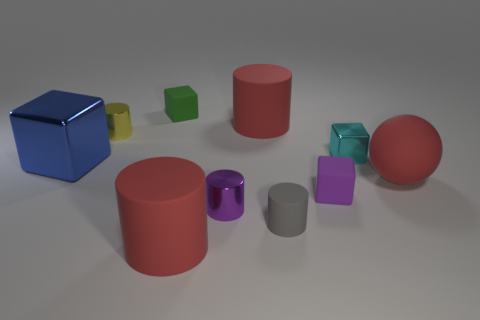Are there any other things that are the same shape as the tiny purple shiny thing?
Offer a very short reply. Yes. The big thing that is on the left side of the matte block behind the blue metal thing is made of what material?
Offer a terse response. Metal. How big is the red matte ball that is to the right of the small purple shiny object?
Your response must be concise. Large. There is a large matte object that is left of the cyan object and behind the tiny gray rubber object; what color is it?
Ensure brevity in your answer.  Red. There is a red matte cylinder behind the red rubber ball; is it the same size as the green rubber object?
Offer a very short reply. No. Is there a tiny gray matte cylinder to the left of the metal cylinder that is behind the tiny cyan shiny object?
Offer a very short reply. No. What is the material of the red ball?
Your answer should be compact. Rubber. Are there any gray objects to the left of the purple shiny thing?
Offer a very short reply. No. What size is the purple thing that is the same shape as the small gray matte thing?
Provide a succinct answer. Small. Is the number of yellow cylinders that are behind the small purple matte block the same as the number of tiny yellow cylinders that are left of the blue object?
Your answer should be compact. No. 